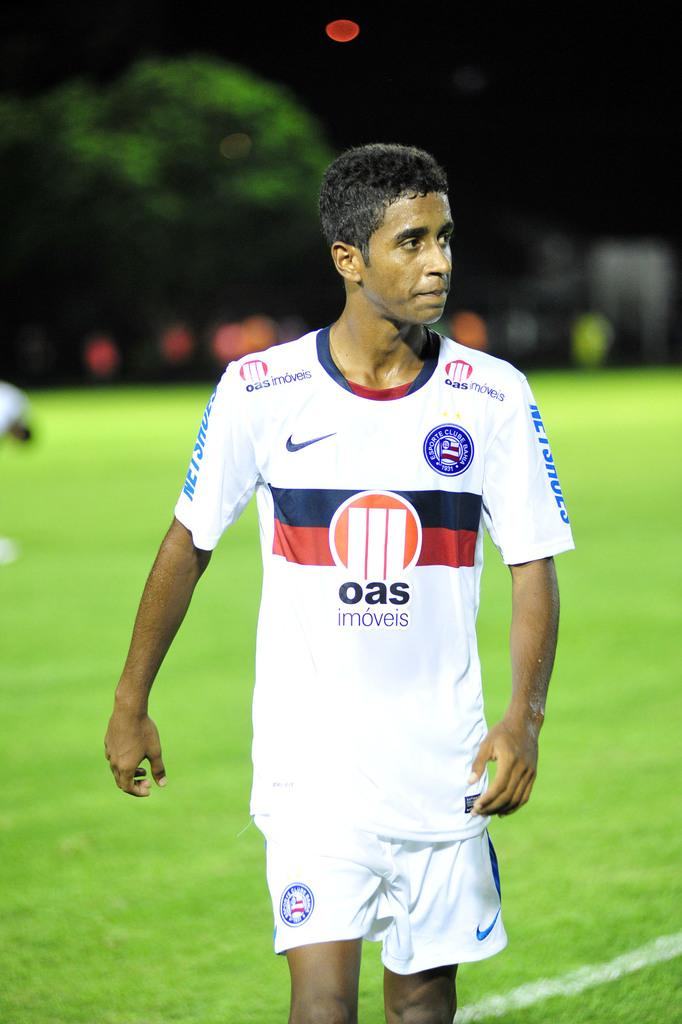<image>
Provide a brief description of the given image. A rugby player on the field his jersey says oas imoveis 